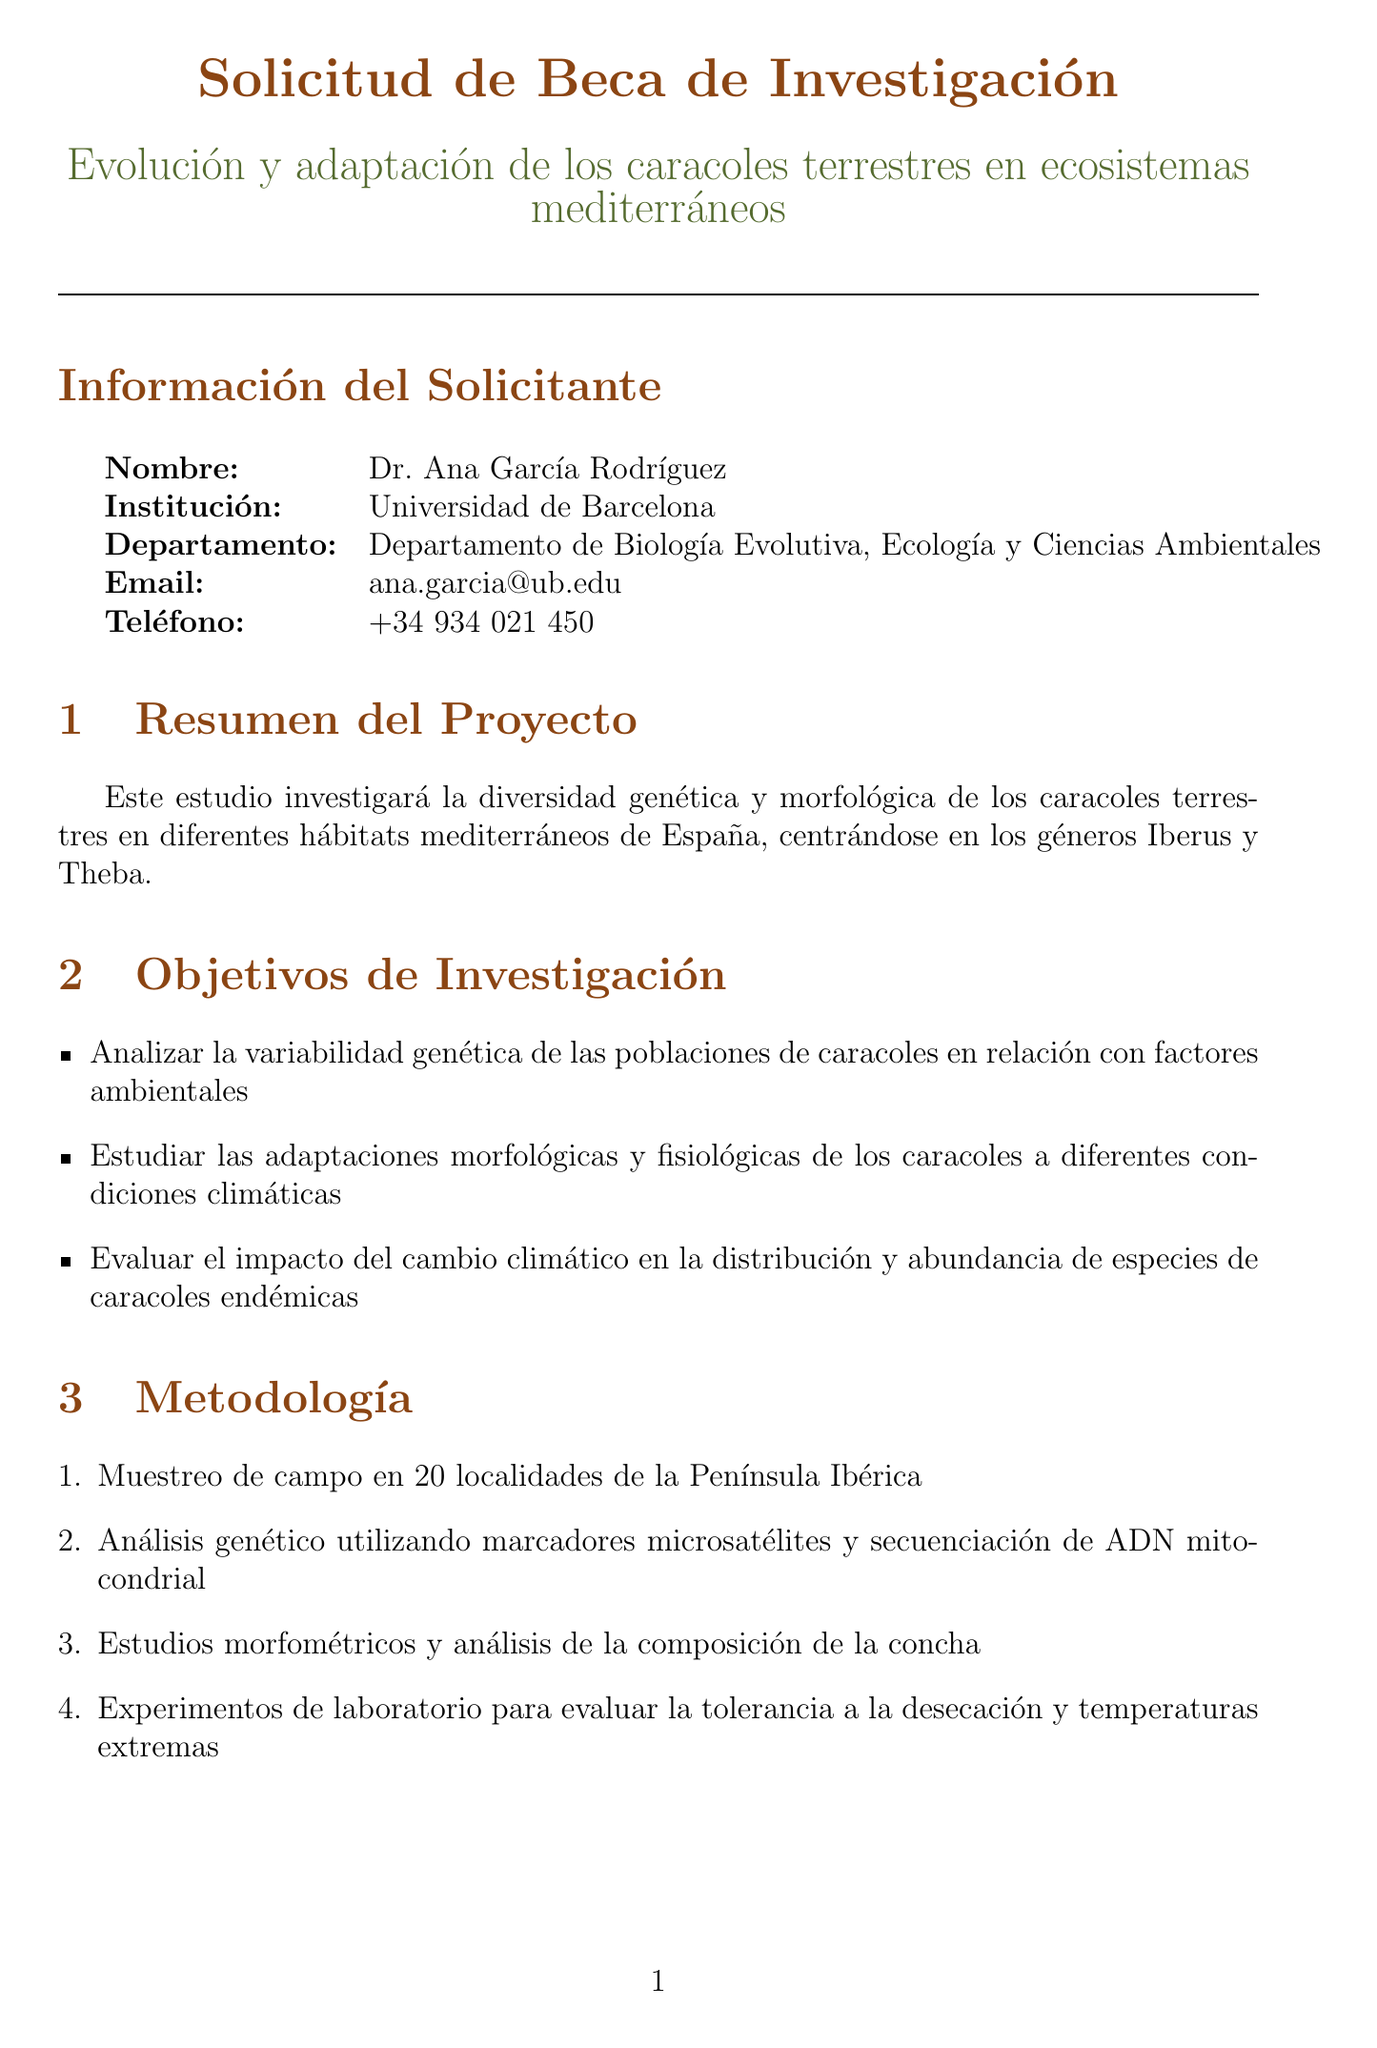¿Cuál es el título del proyecto? El título del proyecto es lo que se indica en la sección correspondiente del documento, en este caso, "Evolución y adaptación de los caracoles terrestres en ecosistemas mediterráneos".
Answer: Evolución y adaptación de los caracoles terrestres en ecosistemas mediterráneos ¿Cuál es el presupuesto total del proyecto? El presupuesto total se especifica claramente en la sección de presupuesto en el documento.
Answer: 180000 ¿Cuántos meses durará la fase de trabajo de campo? La duración de la fase de trabajo de campo se menciona en la tabla del cronograma del proyecto.
Answer: 6 meses ¿Qué metodología se utilizará para analizar la variabilidad genética? Se detalla en la sección de metodología, donde se menciona el uso de "marcadores microsatélites y secuenciación de ADN mitocondrial".
Answer: Marcadores microsatélites y secuenciación de ADN mitocondrial ¿Cuál es el primer objetivo de investigación? El primer objetivo de investigación se encuentra en la lista de objetivos de investigación del documento, que se centra en la variabilidad genética de las poblaciones.
Answer: Analizar la variabilidad genética de las poblaciones de caracoles en relación con factores ambientales ¿Qué institución colaboradora se encuentra en Madrid? Se menciona en la sección de instituciones colaboradoras, donde se identifica una institución ubicada en Madrid, España.
Answer: Museo Nacional de Ciencias Naturales ¿Cuántos artículos se espera publicar? Se menciona bajo "Resultados Esperados" que se prevé la publicación de un número específico de artículos.
Answer: 3 ¿Cuál es la duración de la fase de análisis de datos? La duración de la fase de análisis de datos se indica en la tabla del cronograma, junto con sus actividades asociadas.
Answer: 4 meses 